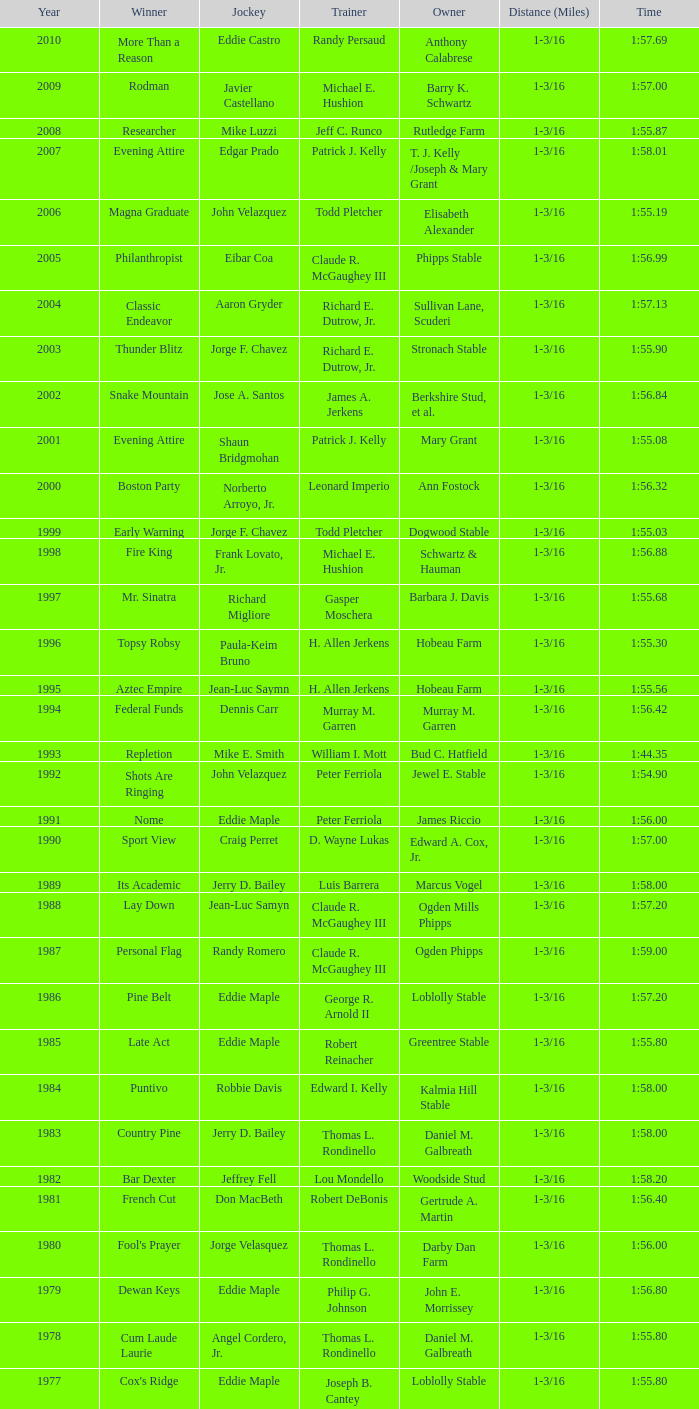Which horse achieved victory under the guidance of a trainer with a "no race" background? No Race, No Race, No Race, No Race. 